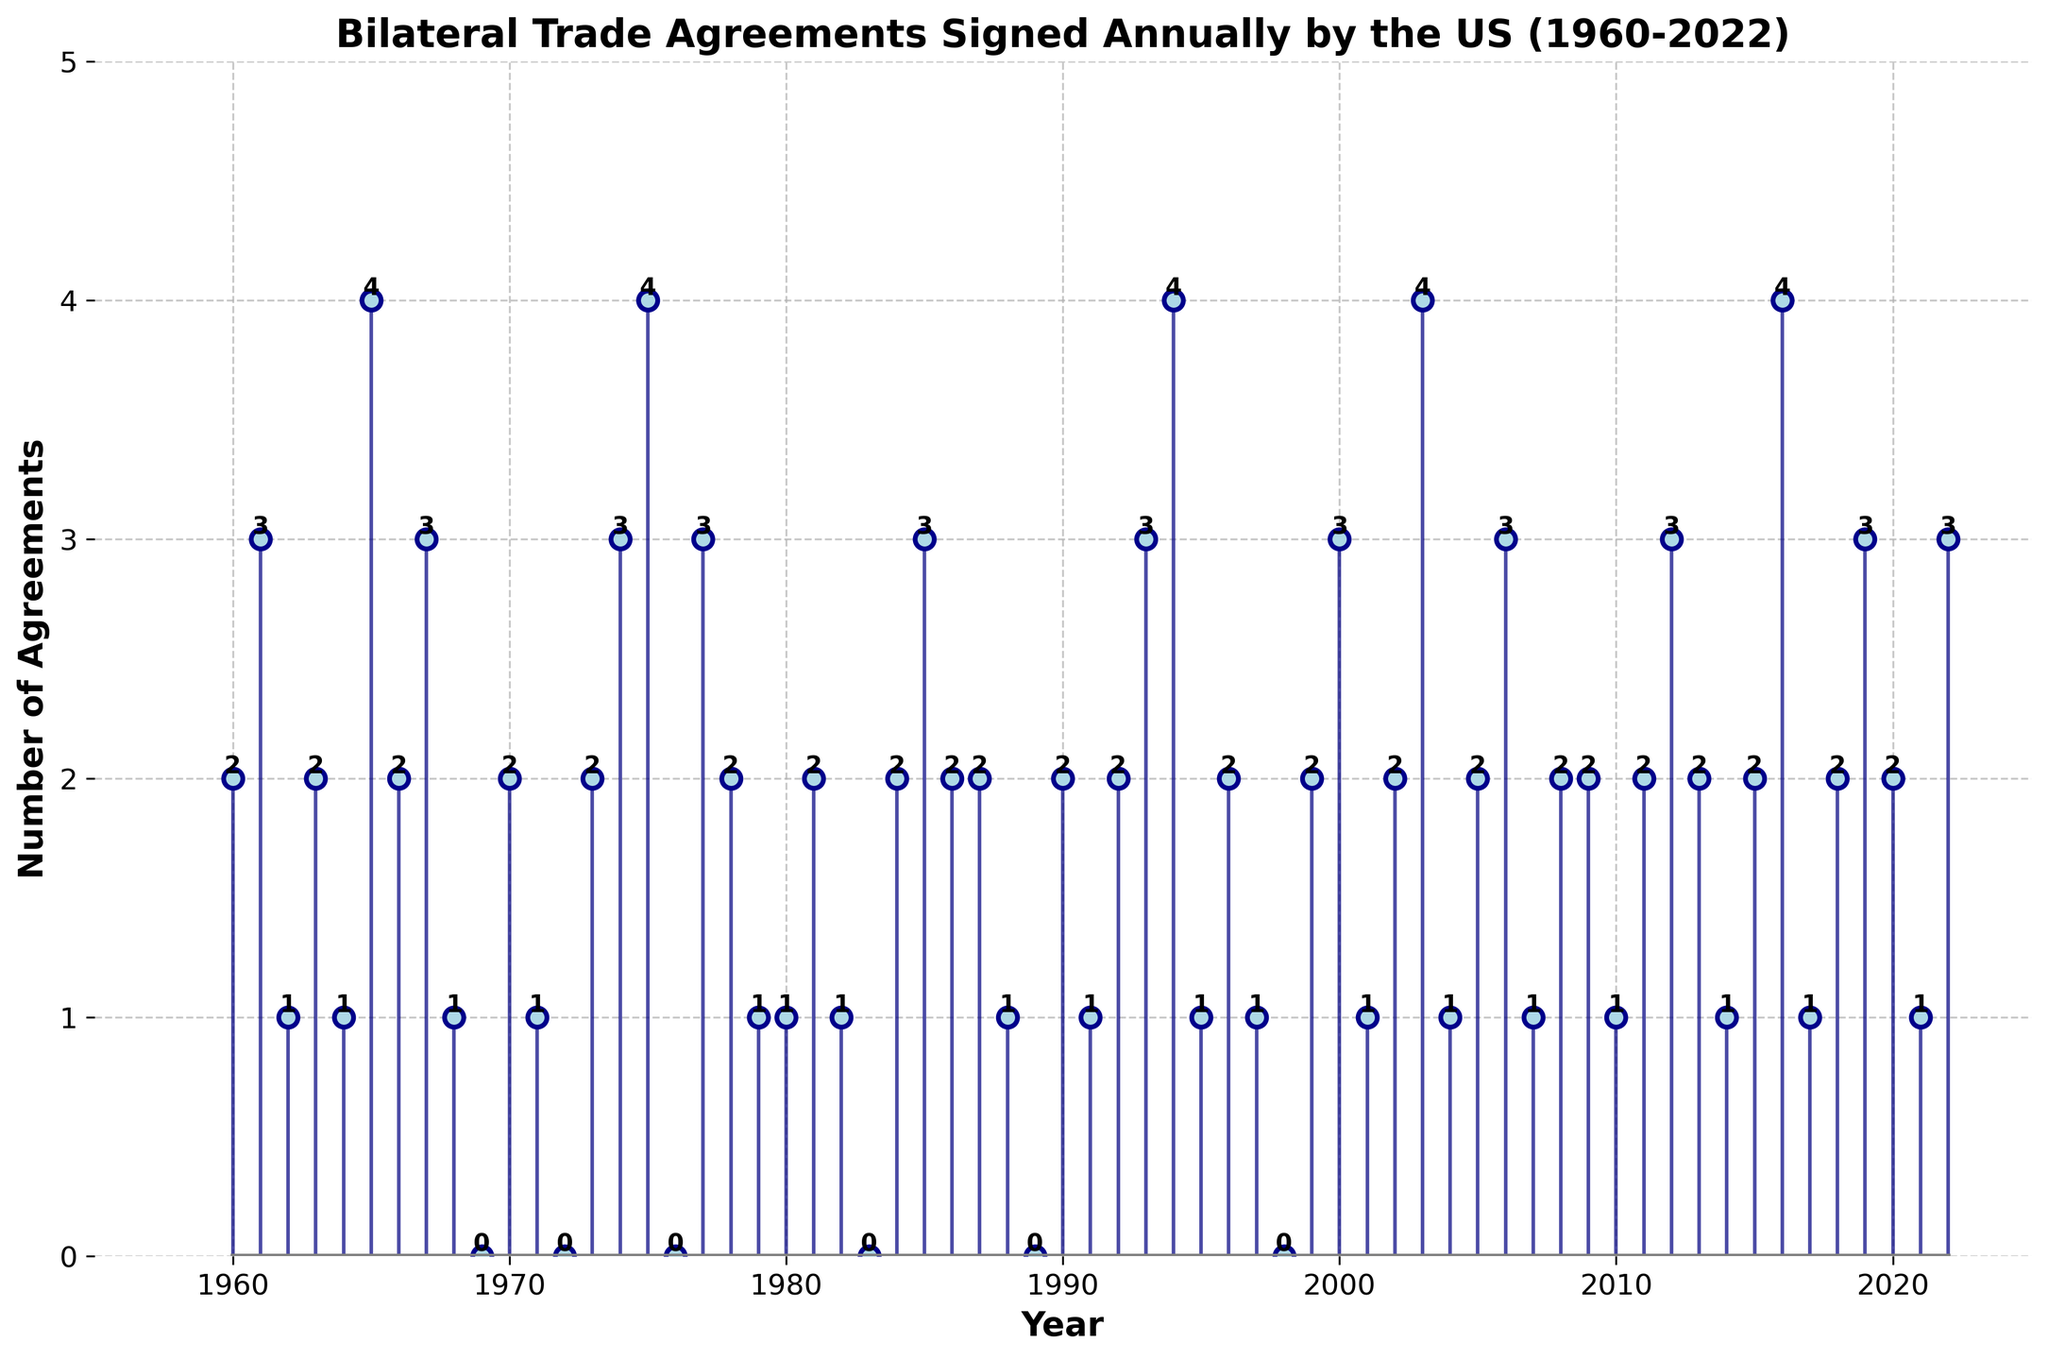What's the title of the plot? The title of the plot is usually displayed prominently at the top. In this case, it states "Bilateral Trade Agreements Signed Annually by the US (1960-2022)."
Answer: Bilateral Trade Agreements Signed Annually by the US (1960-2022) How many bilateral trade agreements did the US sign in 1984? Find the year 1984 on the x-axis and look at the corresponding stem. The stem reaches up to the value 2 on the y-axis.
Answer: 2 In which years did the US sign exactly 4 bilateral trade agreements? Check the plot for stems that reach the value 4 on the y-axis and note down the corresponding years from the x-axis. The stems reach up to 4 in the years 1965, 1975, 2003, 2016.
Answer: 1965, 1975, 2003, 2016 What is the overall trend in the number of trade agreements signed from 1960 to 2022? Observe the pattern of the stems over the years. The number fluctuates but doesn't show a consistent upward or downward trend. There are peaks and troughs distributed across the timeline.
Answer: Fluctuating trend Between 1990 and 2000, in which year did the US sign the highest number of trade agreements? Focus on the years 1990 to 2000 and look for the highest stem. The highest stem in this interval reaches up to 3 agreements in the year 2000.
Answer: 2000 What is the average number of trade agreements signed per year from 1960 to 2022? Sum all the values of trade agreements for each year and divide by the number of years (63 years). (2+3+1+2+1+4+2+3+1+0+2+1+0+2+3+4+0+3+2+1+1+2+1+0+2+3+2+2+1+0+2+1+2+3+4+1+2+1+0+2+3+1+2+4+1+2+3+1+2+2+1+2+3+2+1+2+4+1+2+3+2+1+3) = 152/63 ≈ 2.41 agreements per year.
Answer: 2.41 How many years saw no bilateral trade agreements signed? Count the number of stems that reach the value 0 on the y-axis. There are six such points at 1969, 1972, 1976, 1983, 1989, 1998.
Answer: 6 Which year had fewer bilateral trade agreements signed, 1973 or 2004? Compare the heights of the stems for the years 1973 and 2004. The stem for 1973 reaches 2, and the stem for 2004 reaches 1. Therefore, 2004 had fewer agreements.
Answer: 2004 What is the sum of the agreements signed in the years starting with '2' (2000-2022)? Sum the number of trade agreements for all years starting from 2000 to 2022: 3+1+2+4+1+2+3+1+2+2+1+2+3+2+1+2+4+1+2+3+2+1+3 = 43.
Answer: 43 